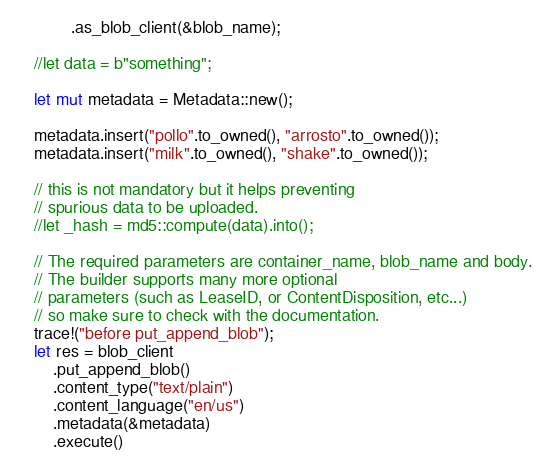<code> <loc_0><loc_0><loc_500><loc_500><_Rust_>            .as_blob_client(&blob_name);

    //let data = b"something";

    let mut metadata = Metadata::new();

    metadata.insert("pollo".to_owned(), "arrosto".to_owned());
    metadata.insert("milk".to_owned(), "shake".to_owned());

    // this is not mandatory but it helps preventing
    // spurious data to be uploaded.
    //let _hash = md5::compute(data).into();

    // The required parameters are container_name, blob_name and body.
    // The builder supports many more optional
    // parameters (such as LeaseID, or ContentDisposition, etc...)
    // so make sure to check with the documentation.
    trace!("before put_append_blob");
    let res = blob_client
        .put_append_blob()
        .content_type("text/plain")
        .content_language("en/us")
        .metadata(&metadata)
        .execute()</code> 